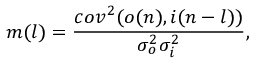Convert formula to latex. <formula><loc_0><loc_0><loc_500><loc_500>m ( l ) = \frac { c o v ^ { 2 } ( o ( n ) , i ( n - l ) ) } { \sigma _ { o } ^ { 2 } \sigma _ { i } ^ { 2 } } ,</formula> 